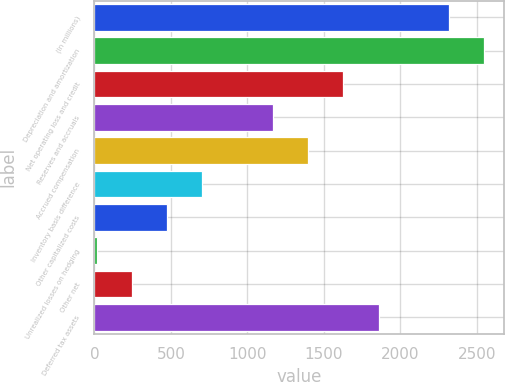Convert chart. <chart><loc_0><loc_0><loc_500><loc_500><bar_chart><fcel>(In millions)<fcel>Depreciation and amortization<fcel>Net operating loss and credit<fcel>Reserves and accruals<fcel>Accrued compensation<fcel>Inventory basis difference<fcel>Other capitalized costs<fcel>Unrealized losses on hedging<fcel>Other net<fcel>Deferred tax assets<nl><fcel>2319.1<fcel>2549.54<fcel>1627.78<fcel>1166.9<fcel>1397.34<fcel>706.02<fcel>475.58<fcel>14.7<fcel>245.14<fcel>1858.22<nl></chart> 